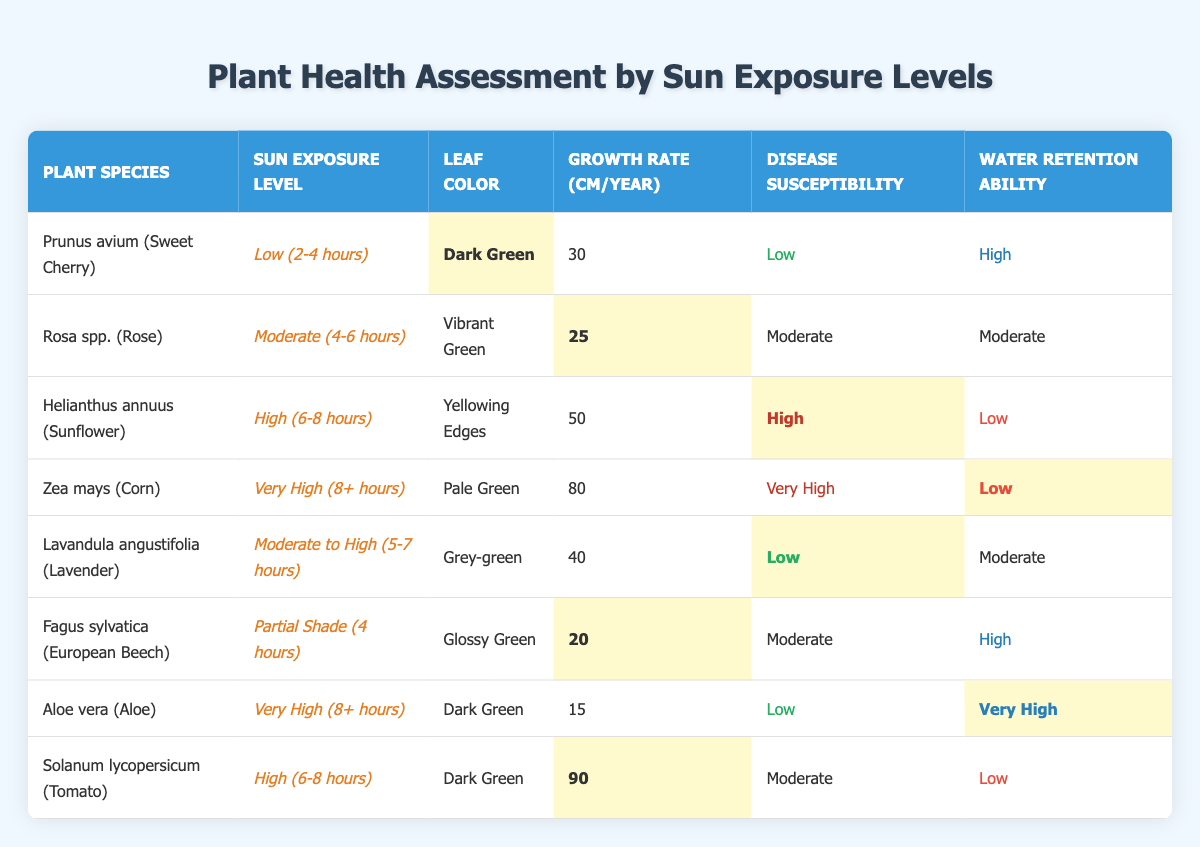What is the leaf color of Prunus avium (Sweet Cherry)? The table shows that the leaf color for Prunus avium (Sweet Cherry) is listed as "Dark Green."
Answer: Dark Green Which plant has the highest growth rate? The growth rates listed in the table are 30, 25, 50, 80, 40, 20, 15, and 90 cm/year. The highest value is 90 cm/year for Solanum lycopersicum (Tomato).
Answer: Solanum lycopersicum (Tomato) True or False: Helianthus annuus (Sunflower) has low disease susceptibility. The table indicates that Helianthus annuus (Sunflower) has "High" disease susceptibility, so the statement is false.
Answer: False What are the water retention abilities of Zea mays (Corn) and Aloe vera (Aloe)? The table states that Zea mays (Corn) has "Low" water retention ability and Aloe vera (Aloe) has "Very High" water retention ability.
Answer: Low and Very High Which plant species experiences very high disease susceptibility? The table lists Zea mays (Corn) with "Very High" disease susceptibility. This is the only plant with that classification.
Answer: Zea mays (Corn) What is the average growth rate of plants with moderate sunlight exposure? The plants with moderate sunlight exposure are Rosa spp. (25 cm/year), Lavandula angustifolia (40 cm/year), and Fagus sylvatica (20 cm/year). Adding these values gives 25 + 40 + 20 = 85 cm. Dividing by 3 gives an average of 28.33 cm/year.
Answer: 28.33 cm/year Which plant species has vibrant green leaves and what is its growth rate? The table shows that Rosa spp. (Rose) has "Vibrant Green" leaves and a growth rate of 25 cm/year.
Answer: Rosa spp. (25 cm/year) Is there a plant with a high disease susceptibility that also has a low water retention ability? The data indicates that Helianthus annuus (Sunflower) has "High" disease susceptibility and "Low" water retention ability, fitting the criteria.
Answer: Yes What is the leaf color of the plant species that prefers partial shade? The table states that Fagus sylvatica (European Beech), which prefers partial shade, has a leaf color of "Glossy Green."
Answer: Glossy Green Identify the plant species with the lowest growth rate and state its water retention ability. The plant with the lowest growth rate is Aloe vera (Aloe) with a growth rate of 15 cm/year, and its water retention ability is "Very High."
Answer: Aloe vera (Very High) 